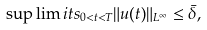<formula> <loc_0><loc_0><loc_500><loc_500>\sup \lim i t s _ { 0 < t < T } \| u ( t ) \| _ { L ^ { \infty } } \leq \bar { \delta } ,</formula> 